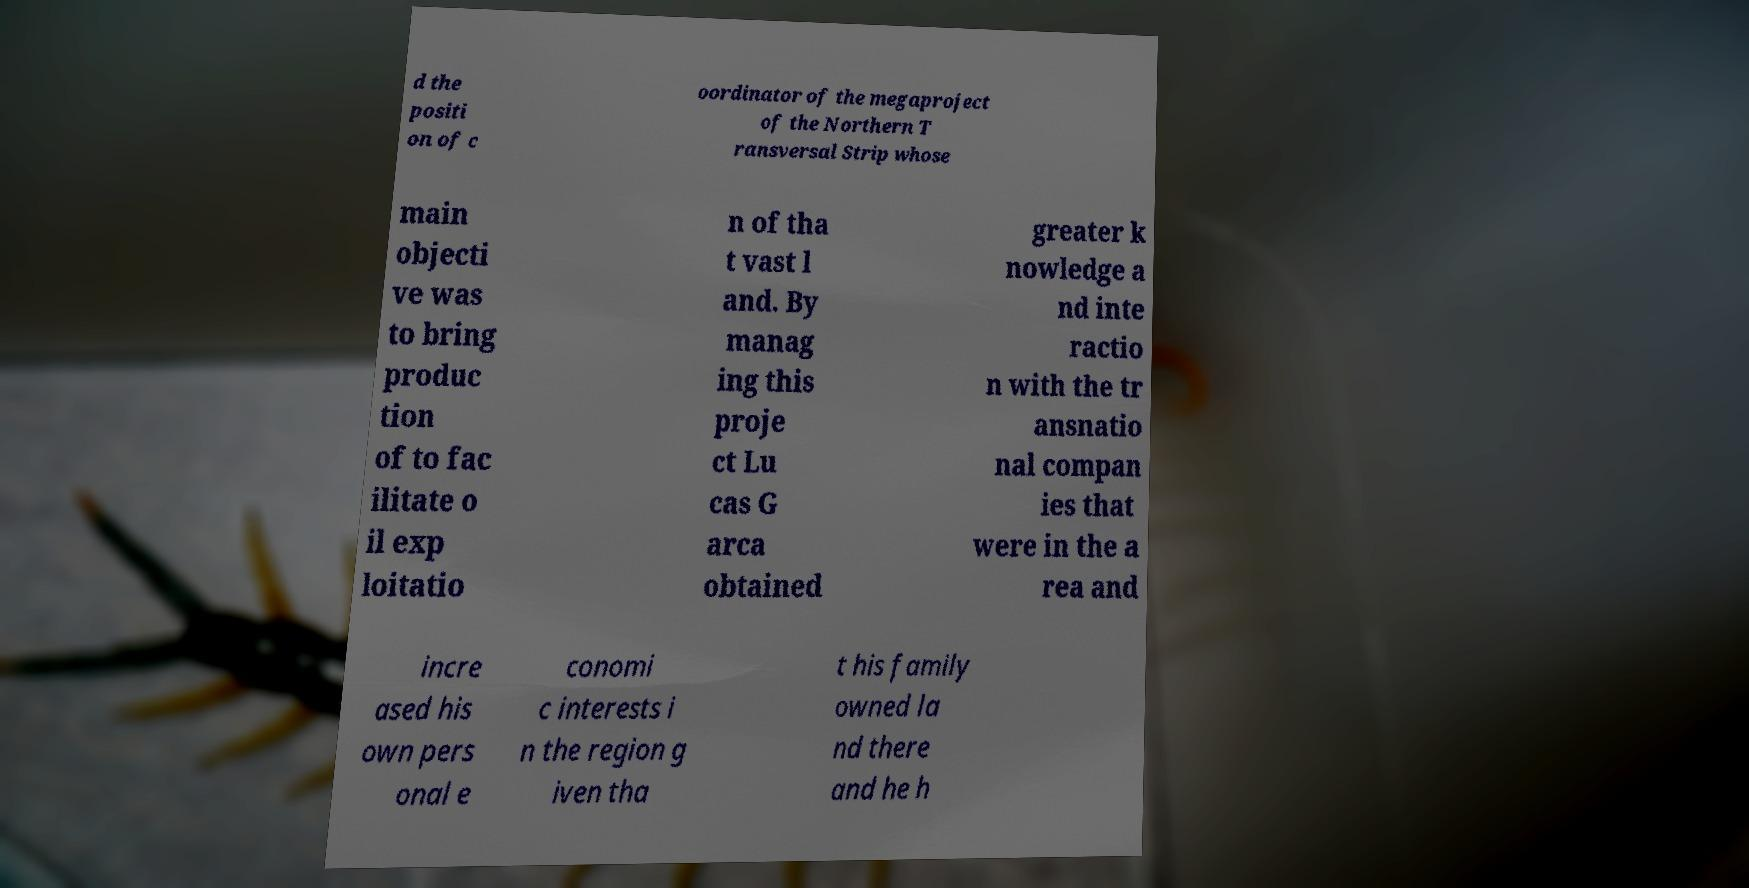Could you assist in decoding the text presented in this image and type it out clearly? d the positi on of c oordinator of the megaproject of the Northern T ransversal Strip whose main objecti ve was to bring produc tion of to fac ilitate o il exp loitatio n of tha t vast l and. By manag ing this proje ct Lu cas G arca obtained greater k nowledge a nd inte ractio n with the tr ansnatio nal compan ies that were in the a rea and incre ased his own pers onal e conomi c interests i n the region g iven tha t his family owned la nd there and he h 